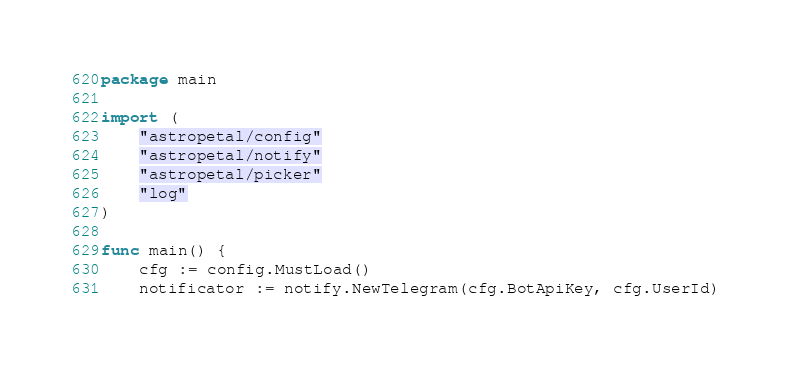<code> <loc_0><loc_0><loc_500><loc_500><_Go_>package main

import (
	"astropetal/config"
	"astropetal/notify"
	"astropetal/picker"
	"log"
)

func main() {
	cfg := config.MustLoad()
	notificator := notify.NewTelegram(cfg.BotApiKey, cfg.UserId)</code> 